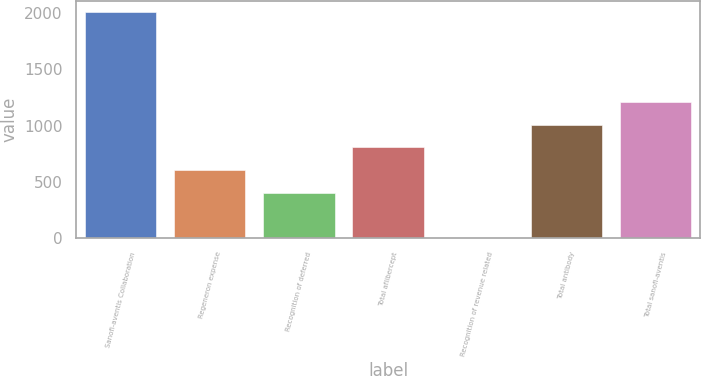Convert chart to OTSL. <chart><loc_0><loc_0><loc_500><loc_500><bar_chart><fcel>Sanofi-aventis Collaboration<fcel>Regeneron expense<fcel>Recognition of deferred<fcel>Total aflibercept<fcel>Recognition of revenue related<fcel>Total antibody<fcel>Total sanofi-aventis<nl><fcel>2009<fcel>604.59<fcel>403.96<fcel>805.22<fcel>2.7<fcel>1005.85<fcel>1206.48<nl></chart> 